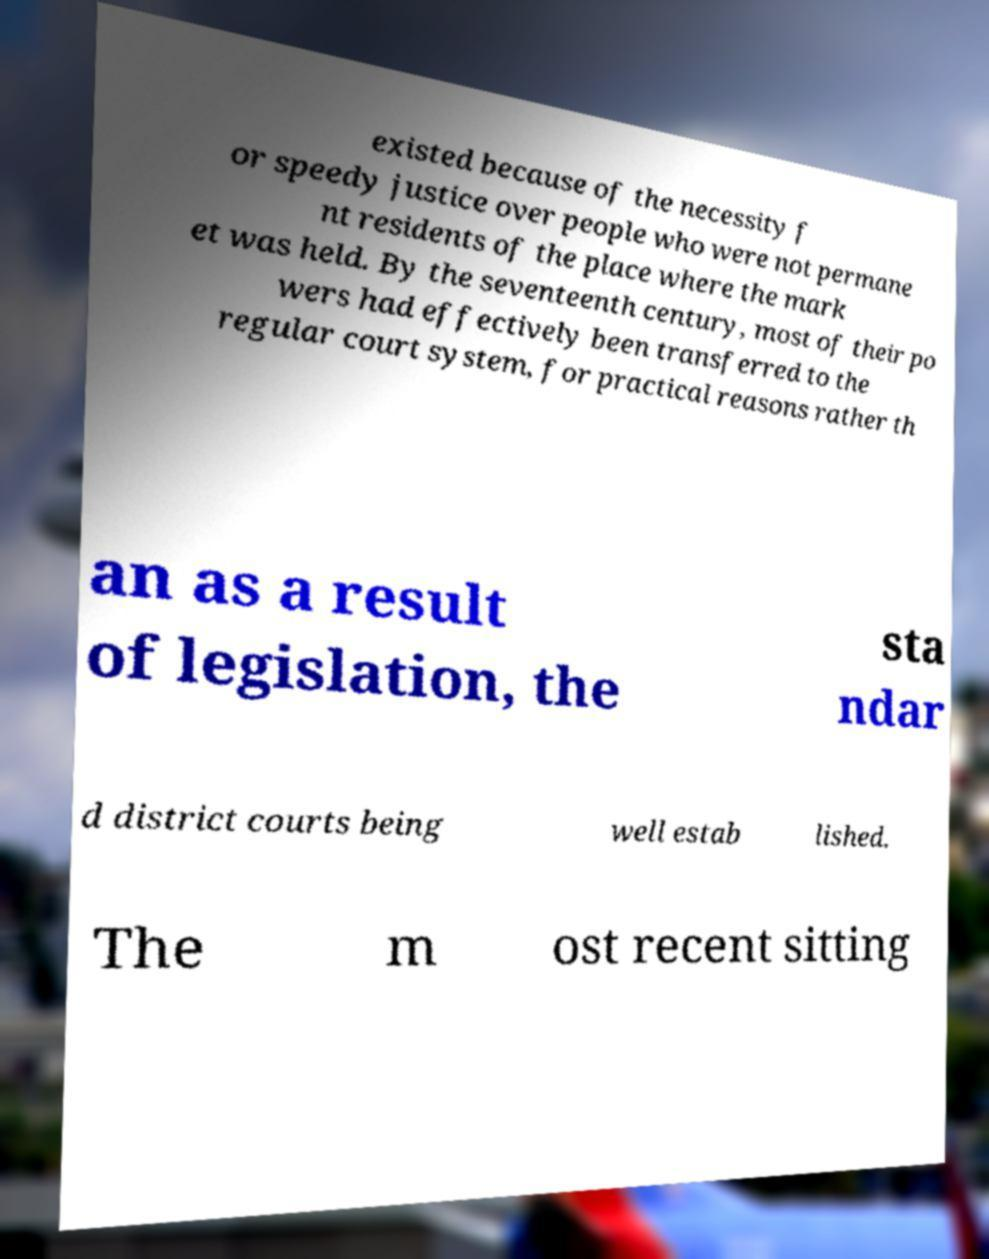I need the written content from this picture converted into text. Can you do that? existed because of the necessity f or speedy justice over people who were not permane nt residents of the place where the mark et was held. By the seventeenth century, most of their po wers had effectively been transferred to the regular court system, for practical reasons rather th an as a result of legislation, the sta ndar d district courts being well estab lished. The m ost recent sitting 